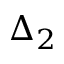<formula> <loc_0><loc_0><loc_500><loc_500>\Delta _ { 2 }</formula> 